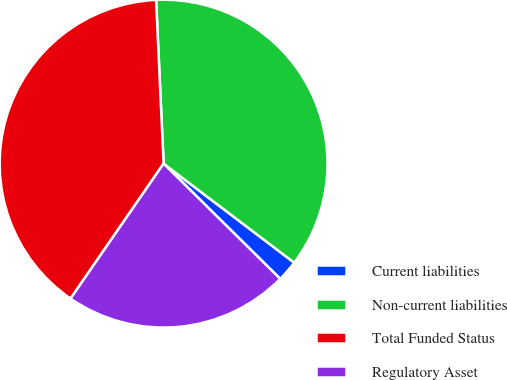<chart> <loc_0><loc_0><loc_500><loc_500><pie_chart><fcel>Current liabilities<fcel>Non-current liabilities<fcel>Total Funded Status<fcel>Regulatory Asset<nl><fcel>2.08%<fcel>36.05%<fcel>39.66%<fcel>22.2%<nl></chart> 